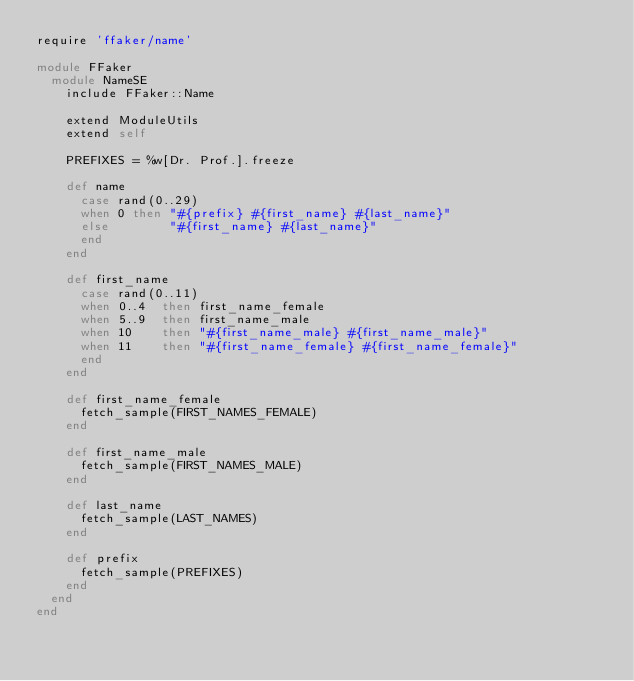Convert code to text. <code><loc_0><loc_0><loc_500><loc_500><_Ruby_>require 'ffaker/name'

module FFaker
  module NameSE
    include FFaker::Name

    extend ModuleUtils
    extend self

    PREFIXES = %w[Dr. Prof.].freeze

    def name
      case rand(0..29)
      when 0 then "#{prefix} #{first_name} #{last_name}"
      else        "#{first_name} #{last_name}"
      end
    end

    def first_name
      case rand(0..11)
      when 0..4  then first_name_female
      when 5..9  then first_name_male
      when 10    then "#{first_name_male} #{first_name_male}"
      when 11    then "#{first_name_female} #{first_name_female}"
      end
    end

    def first_name_female
      fetch_sample(FIRST_NAMES_FEMALE)
    end

    def first_name_male
      fetch_sample(FIRST_NAMES_MALE)
    end

    def last_name
      fetch_sample(LAST_NAMES)
    end

    def prefix
      fetch_sample(PREFIXES)
    end
  end
end
</code> 